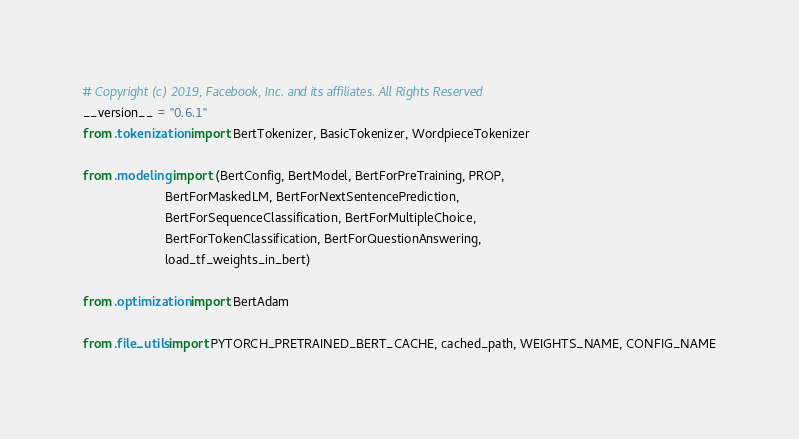<code> <loc_0><loc_0><loc_500><loc_500><_Python_># Copyright (c) 2019, Facebook, Inc. and its affiliates. All Rights Reserved
__version__ = "0.6.1"
from .tokenization import BertTokenizer, BasicTokenizer, WordpieceTokenizer

from .modeling import (BertConfig, BertModel, BertForPreTraining, PROP,
                       BertForMaskedLM, BertForNextSentencePrediction,
                       BertForSequenceClassification, BertForMultipleChoice,
                       BertForTokenClassification, BertForQuestionAnswering,
                       load_tf_weights_in_bert)

from .optimization import BertAdam

from .file_utils import PYTORCH_PRETRAINED_BERT_CACHE, cached_path, WEIGHTS_NAME, CONFIG_NAME
</code> 